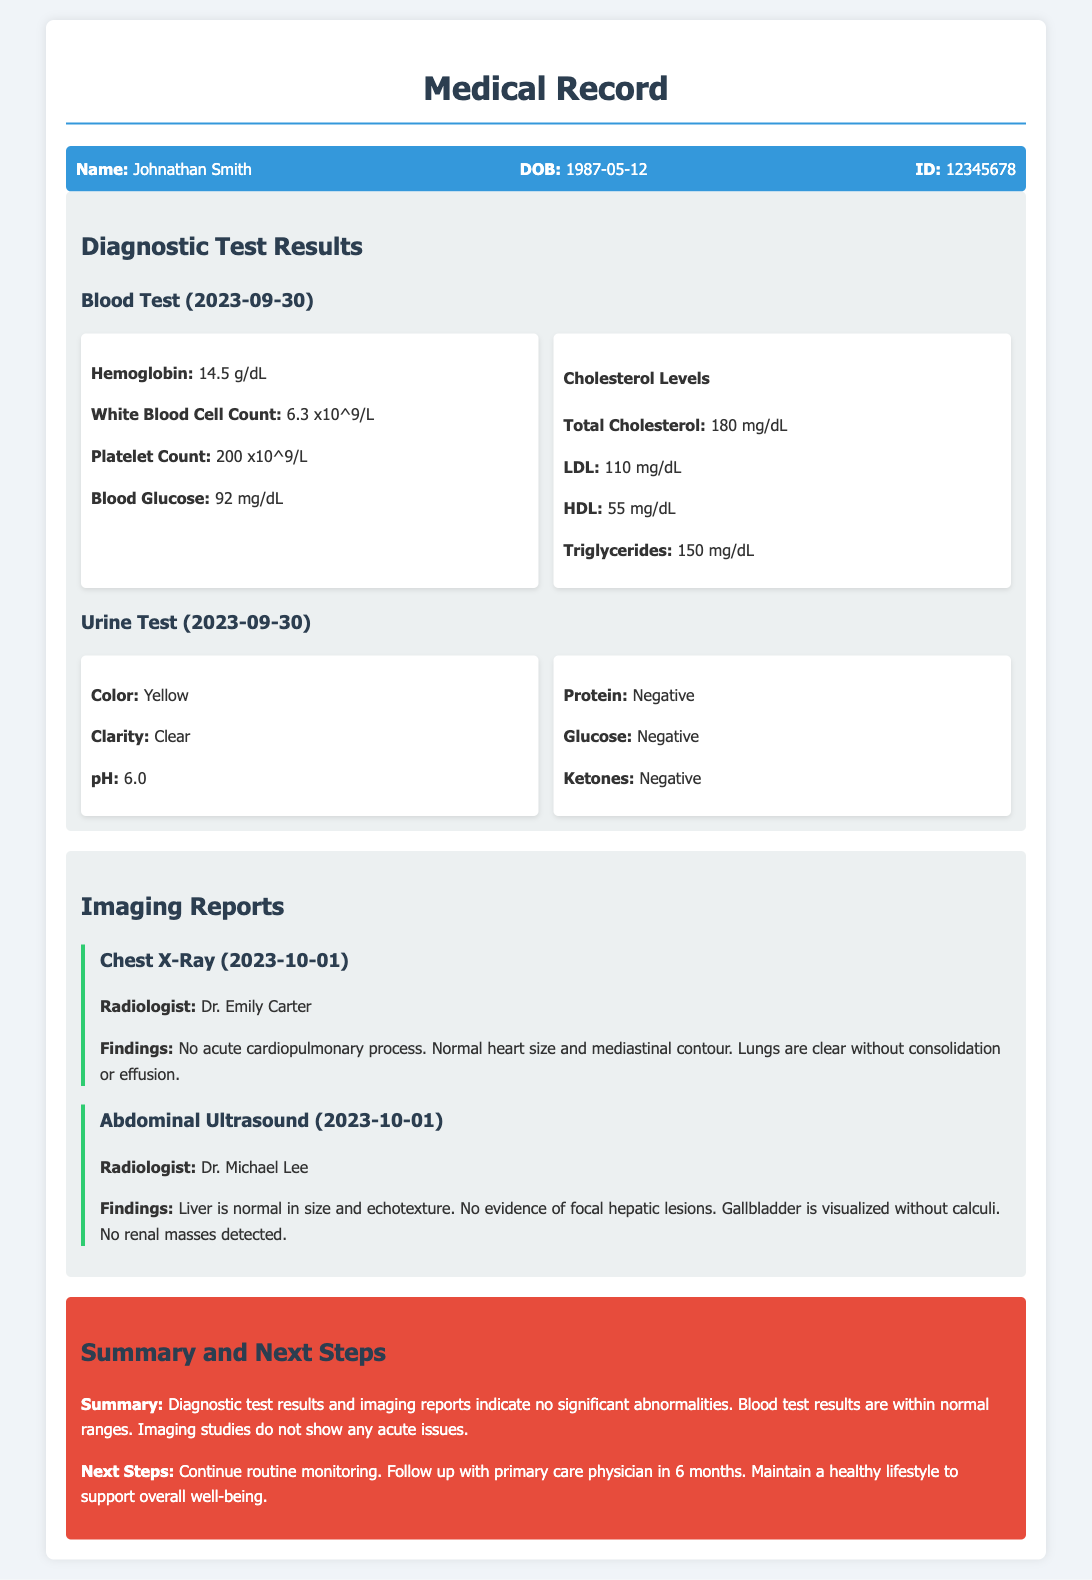What is the patient's name? The patient's name is mentioned at the top of the document in the patient info section.
Answer: Johnathan Smith What is the date of the blood test? The blood test date is provided in the diagnostic test results section under blood test.
Answer: 2023-09-30 What were Johnathan's cholesterol levels? The cholesterol levels are detailed in the Blood Test results under Cholesterol Levels.
Answer: Total Cholesterol: 180 mg/dL, LDL: 110 mg/dL, HDL: 55 mg/dL, Triglycerides: 150 mg/dL Who conducted the Chest X-Ray? The imaging report specifies the name of the radiologist who performed the Chest X-Ray.
Answer: Dr. Emily Carter What are the findings from the abdominal ultrasound? The findings from the abdominal ultrasound are clearly stated in the imaging report section, summarizing the results of the examination.
Answer: Liver is normal in size and echotexture. No evidence of focal hepatic lesions. Gallbladder is visualized without calculi. No renal masses detected What is the summary conclusion of the diagnostic tests? The summary section gives a conclusion regarding the results of the tests conducted and their significance.
Answer: Diagnostic test results and imaging reports indicate no significant abnormalities How long should Johnathan wait to follow up with his primary care physician? The next steps mention when to follow up with the primary care physician.
Answer: 6 months What is the pH level reported in the urine test? The pH level is included among the details of the urine test results.
Answer: 6.0 What was the finding regarding the lungs from the Chest X-Ray? The findings include an assessment of the lungs, which is specified in the imaging report section.
Answer: Lungs are clear without consolidation or effusion 